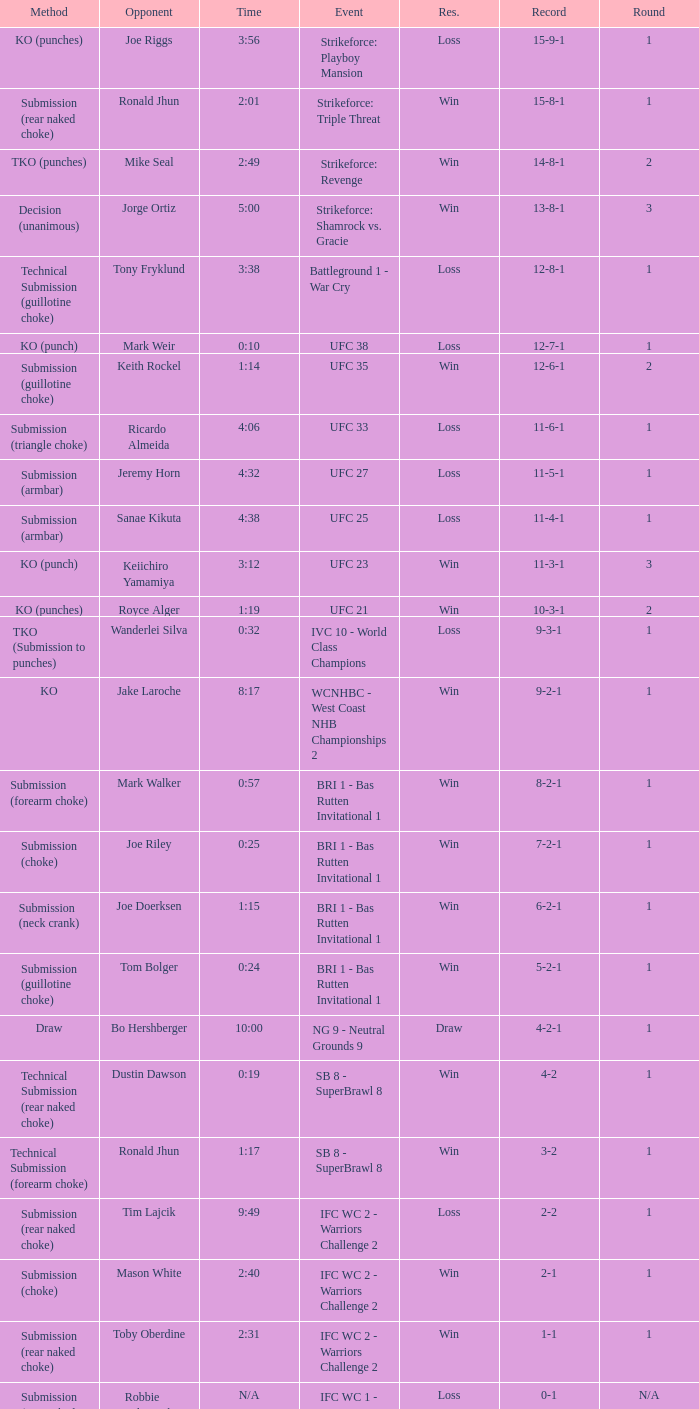What was the record when the method of resolution was KO? 9-2-1. 